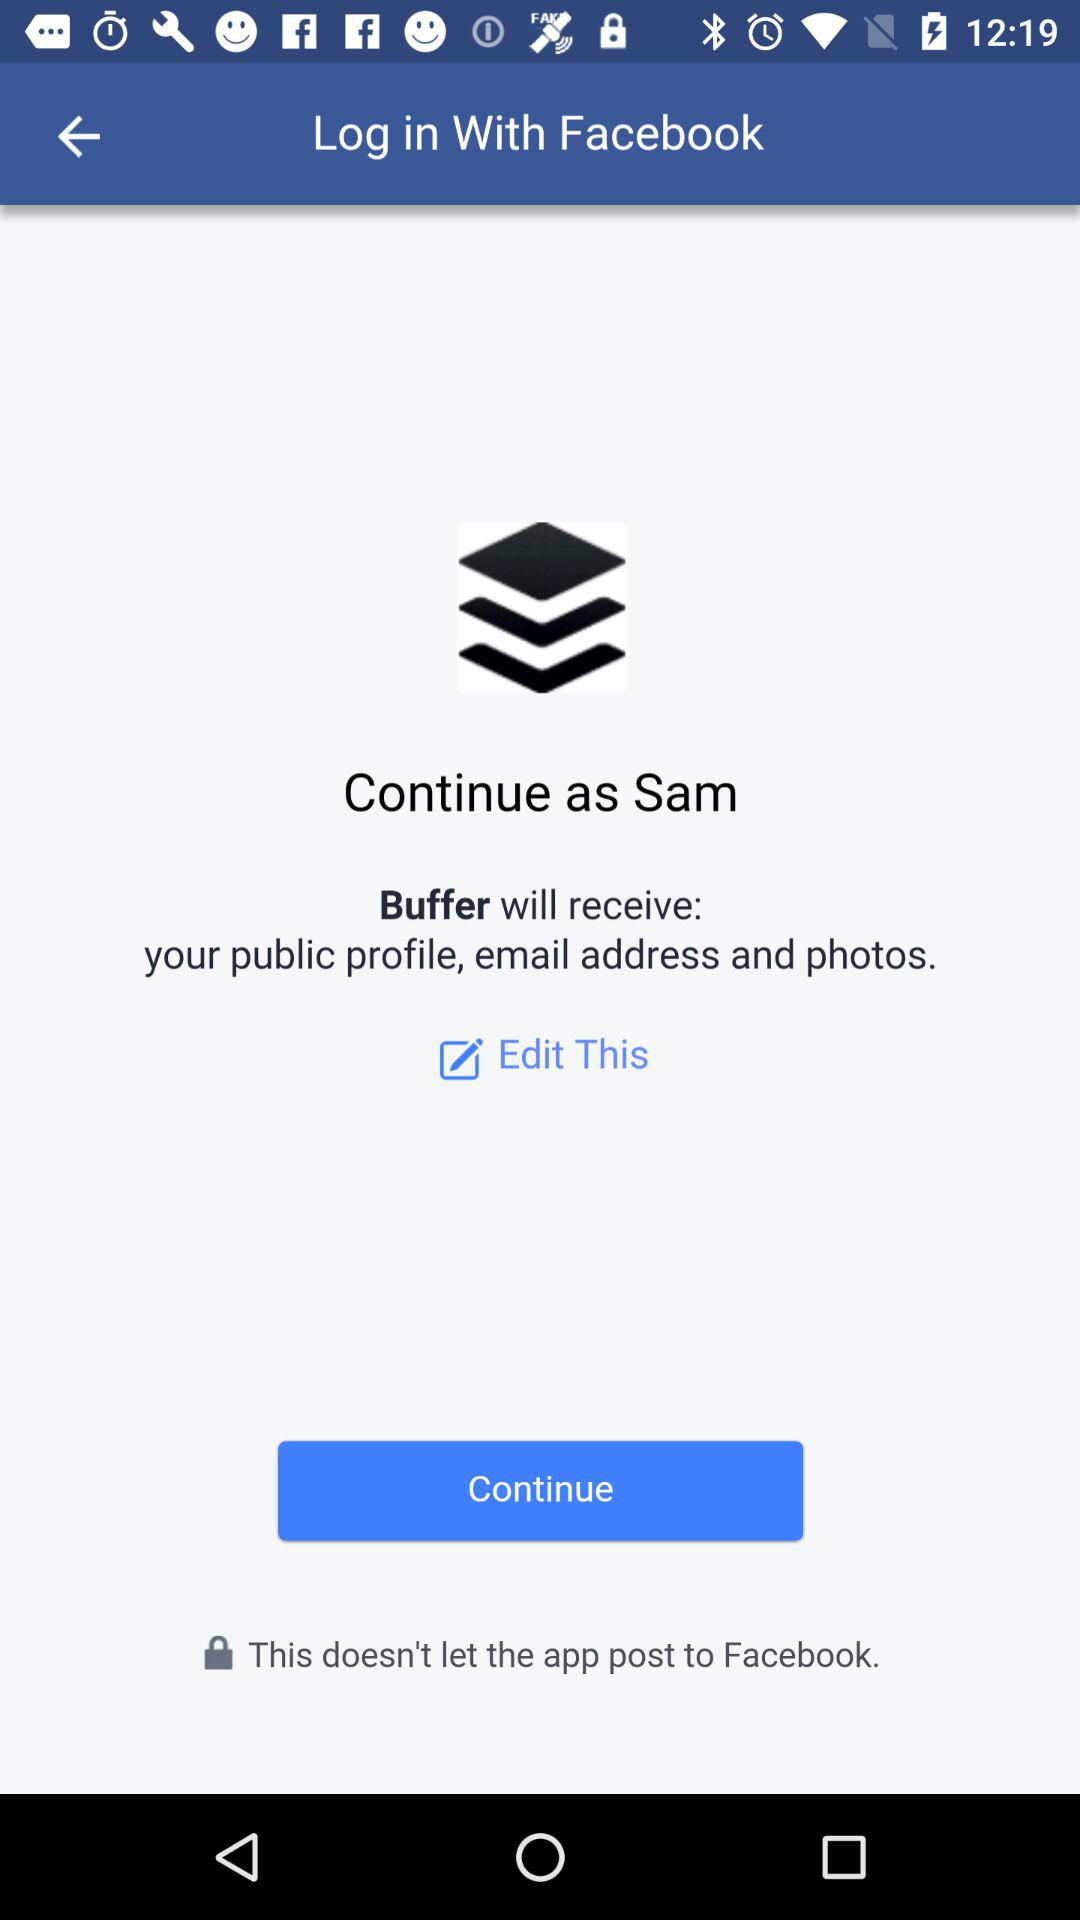What application is asking for permission? The application asking for permission is "Buffer". 